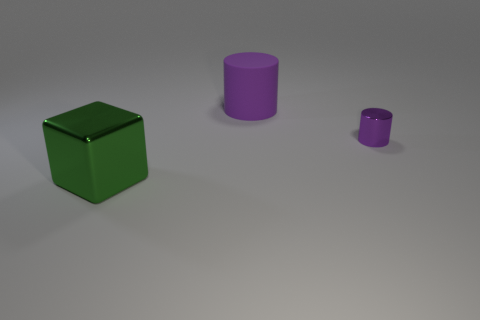Add 2 big purple objects. How many objects exist? 5 Subtract 0 brown cubes. How many objects are left? 3 Subtract all blocks. How many objects are left? 2 Subtract all small gray matte cylinders. Subtract all tiny purple objects. How many objects are left? 2 Add 2 large rubber cylinders. How many large rubber cylinders are left? 3 Add 1 red objects. How many red objects exist? 1 